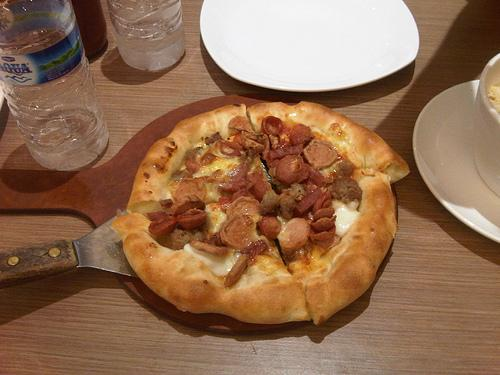What is under the food? spatula 